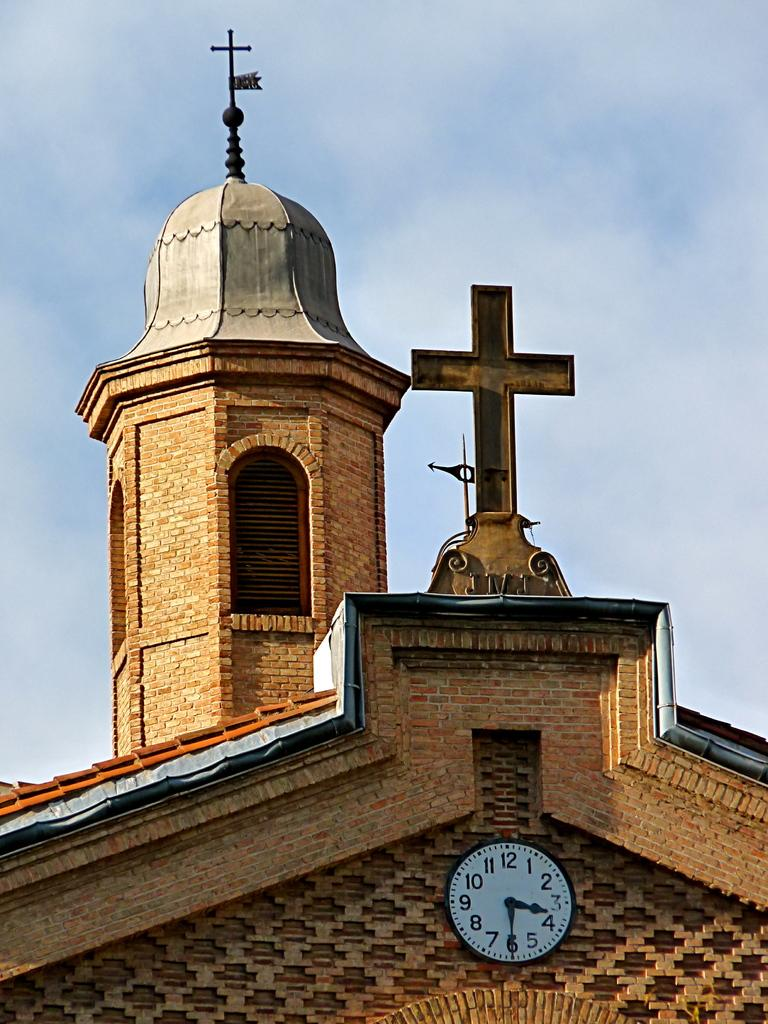<image>
Create a compact narrative representing the image presented. A clock tower, with the clock reading 3:30PM 